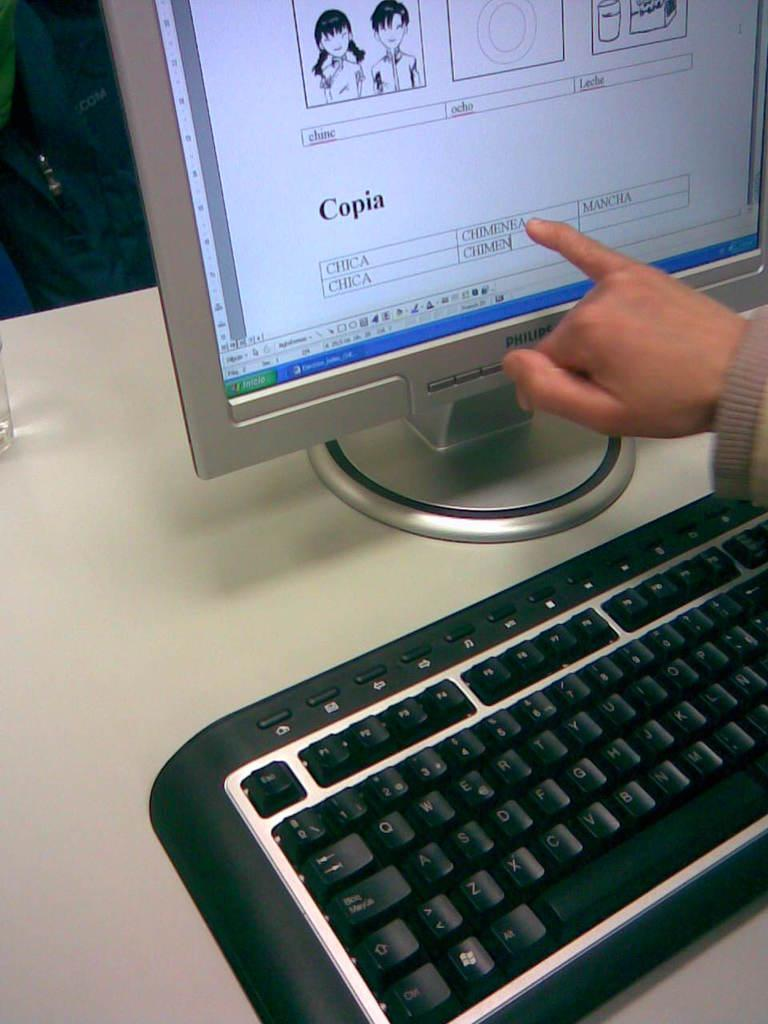<image>
Give a short and clear explanation of the subsequent image. Someone pointing at a computer screen with the word Copia in bold. 